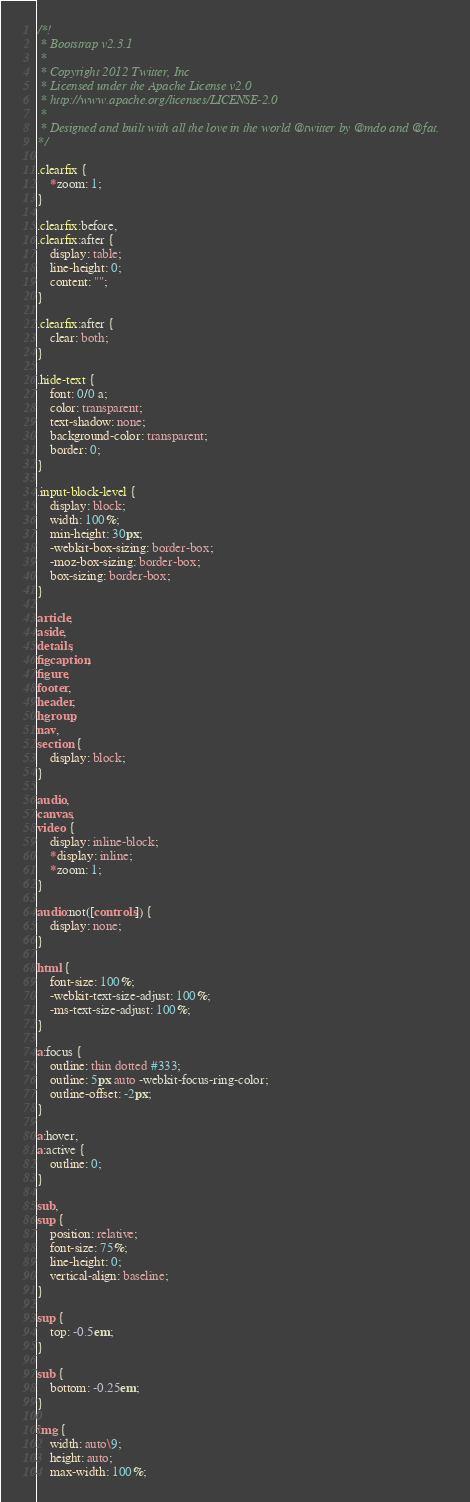<code> <loc_0><loc_0><loc_500><loc_500><_CSS_>/*!
 * Bootstrap v2.3.1
 *
 * Copyright 2012 Twitter, Inc
 * Licensed under the Apache License v2.0
 * http://www.apache.org/licenses/LICENSE-2.0
 *
 * Designed and built with all the love in the world @twitter by @mdo and @fat.
*/

.clearfix {
    *zoom: 1;
}

.clearfix:before,
.clearfix:after {
    display: table;
    line-height: 0;
    content: "";
}

.clearfix:after {
    clear: both;
}

.hide-text {
    font: 0/0 a;
    color: transparent;
    text-shadow: none;
    background-color: transparent;
    border: 0;
}

.input-block-level {
    display: block;
    width: 100%;
    min-height: 30px;
    -webkit-box-sizing: border-box;
    -moz-box-sizing: border-box;
    box-sizing: border-box;
}

article,
aside,
details,
figcaption,
figure,
footer,
header,
hgroup,
nav,
section {
    display: block;
}

audio,
canvas,
video {
    display: inline-block;
    *display: inline;
    *zoom: 1;
}

audio:not([controls]) {
    display: none;
}

html {
    font-size: 100%;
    -webkit-text-size-adjust: 100%;
    -ms-text-size-adjust: 100%;
}

a:focus {
    outline: thin dotted #333;
    outline: 5px auto -webkit-focus-ring-color;
    outline-offset: -2px;
}

a:hover,
a:active {
    outline: 0;
}

sub,
sup {
    position: relative;
    font-size: 75%;
    line-height: 0;
    vertical-align: baseline;
}

sup {
    top: -0.5em;
}

sub {
    bottom: -0.25em;
}

img {
    width: auto\9;
    height: auto;
    max-width: 100%;</code> 